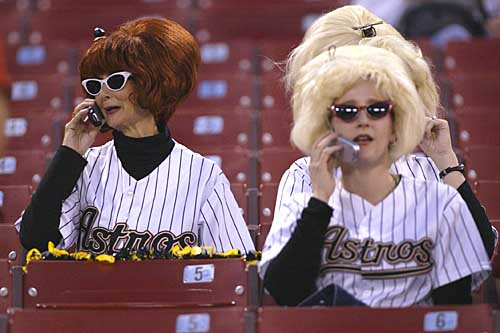Identify the text displayed in this image. Astros 5 6 Astros 